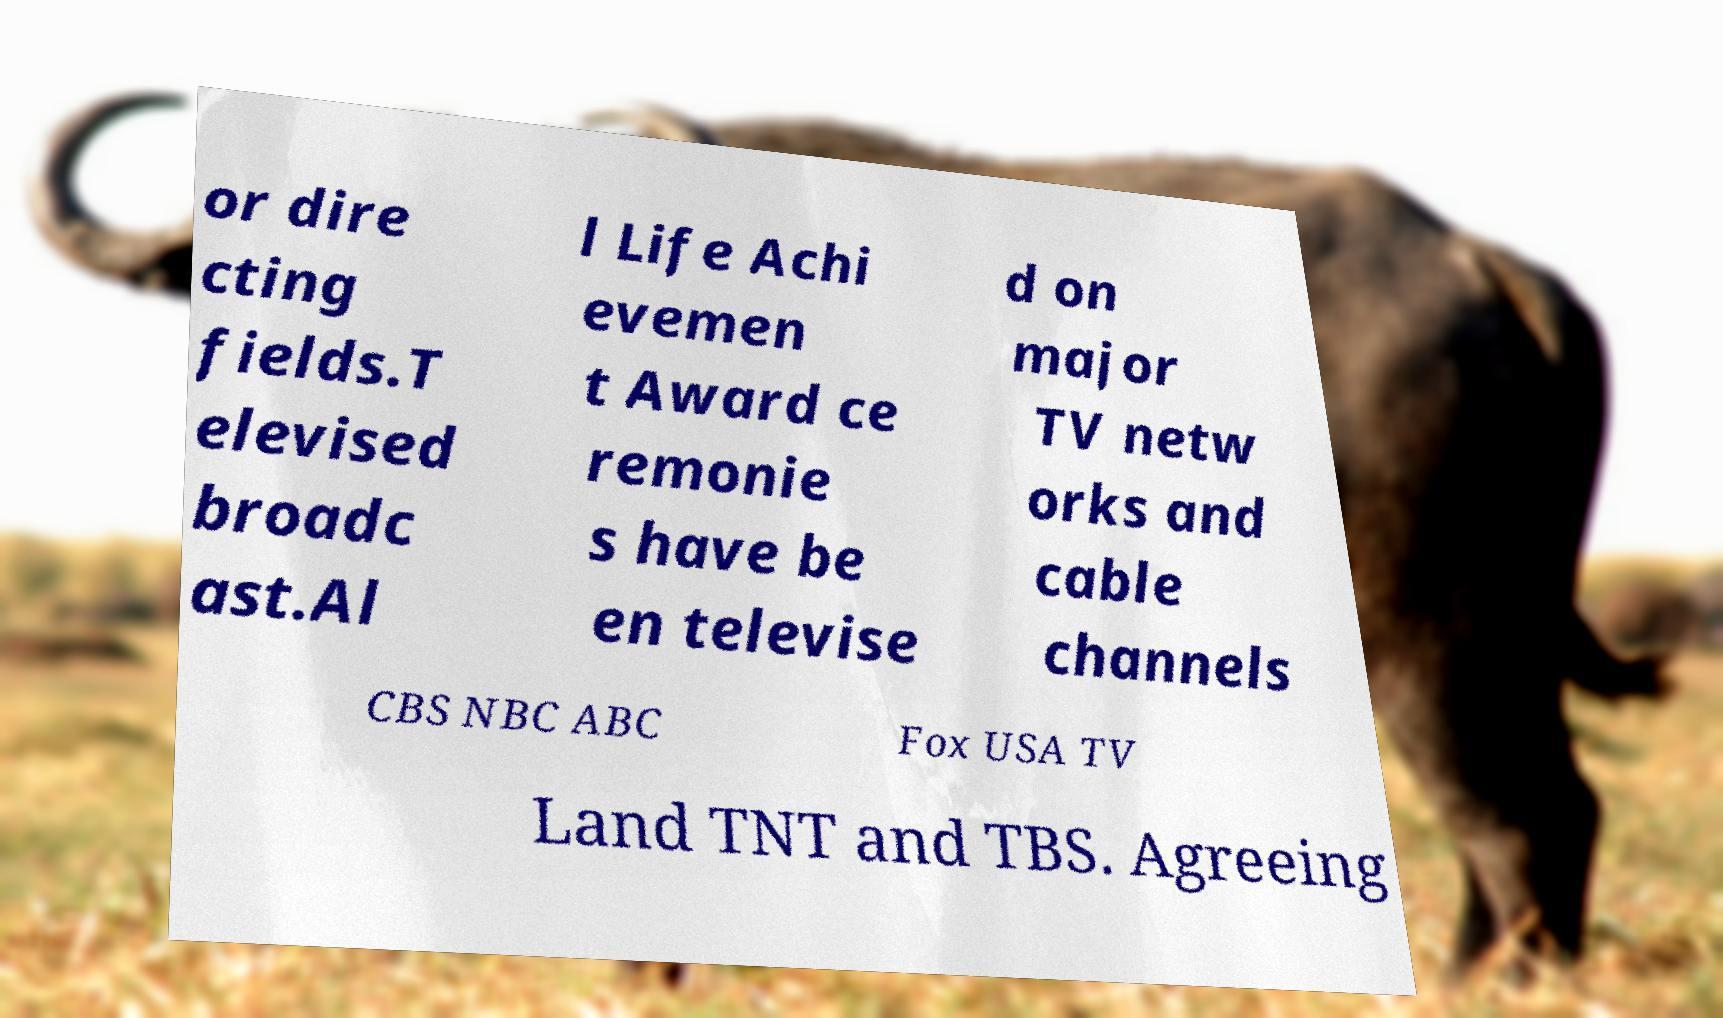What messages or text are displayed in this image? I need them in a readable, typed format. or dire cting fields.T elevised broadc ast.Al l Life Achi evemen t Award ce remonie s have be en televise d on major TV netw orks and cable channels CBS NBC ABC Fox USA TV Land TNT and TBS. Agreeing 